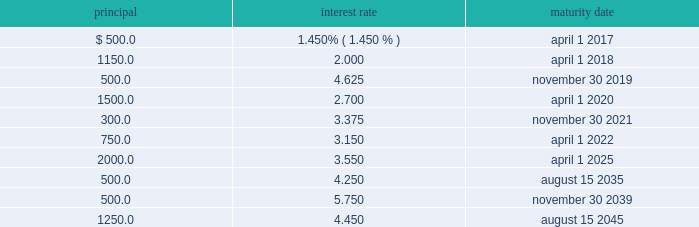Zimmer biomet holdings , inc .
2015 form 10-k annual report through february 25 , 2016 , we repurchased approximately $ 415.0 million of shares of our common stock , which includes the $ 250.0 million of shares that we repurchased from certain selling stockholders on february 10 , 2016 .
In order to achieve operational synergies , we expect cash outlays related to our integration plans to be approximately $ 290.0 million in 2016 .
These cash outlays are necessary to achieve our integration goals of net annual pre-tax operating profit synergies of $ 350.0 million by the end of the third year post-closing date .
Also as discussed in note 20 to our consolidated financial statements , as of december 31 , 2015 , a short-term liability of $ 50.0 million and long-term liability of $ 264.6 million related to durom cup product liability claims was recorded on our consolidated balance sheet .
We expect to continue paying these claims over the next few years .
We expect to be reimbursed a portion of these payments for product liability claims from insurance carriers .
As of december 31 , 2015 , we have received a portion of the insurance proceeds we estimate we will recover .
We have a long-term receivable of $ 95.3 million remaining for future expected reimbursements from our insurance carriers .
We also had a short-term liability of $ 33.4 million related to biomet metal-on-metal hip implant claims .
At december 31 , 2015 , we had ten tranches of senior notes outstanding as follows ( dollars in millions ) : principal interest rate maturity date .
We issued $ 7.65 billion of senior notes in march 2015 ( the 201cmerger notes 201d ) , the proceeds of which were used to finance a portion of the cash consideration payable in the biomet merger , pay merger related fees and expenses and pay a portion of biomet 2019s funded debt .
On june 24 , 2015 , we also borrowed $ 3.0 billion on a u.s .
Term loan ( 201cu.s .
Term loan 201d ) to fund the biomet merger .
We may , at our option , redeem our senior notes , in whole or in part , at any time upon payment of the principal , any applicable make-whole premium , and accrued and unpaid interest to the date of redemption .
In addition , the merger notes and the 3.375% ( 3.375 % ) senior notes due 2021 may be redeemed at our option without any make-whole premium at specified dates ranging from one month to six months in advance of the scheduled maturity date .
We have a $ 4.35 billion credit agreement ( 201ccredit agreement 201d ) that contains : ( i ) a 5-year unsecured u.s .
Term loan facility ( 201cu.s .
Term loan facility 201d ) in the principal amount of $ 3.0 billion , and ( ii ) a 5-year unsecured multicurrency revolving facility ( 201cmulticurrency revolving facility 201d ) in the principal amount of $ 1.35 billion .
The multicurrency revolving facility will mature in may 2019 , with two one-year extensions available at our option .
Borrowings under the multicurrency revolving facility may be used for general corporate purposes .
There were no borrowings outstanding under the multicurrency revolving facility as of december 31 , 2015 .
The u.s .
Term loan facility will mature in june 2020 , with principal payments due beginning september 30 , 2015 , as follows : $ 75.0 million on a quarterly basis during the first three years , $ 112.5 million on a quarterly basis during the fourth year , and $ 412.5 million on a quarterly basis during the fifth year .
In 2015 , we paid $ 500.0 million in principal under the u.s .
Term loan facility , resulting in $ 2.5 billion in outstanding borrowings as of december 31 , we and certain of our wholly owned foreign subsidiaries are the borrowers under the credit agreement .
Borrowings under the credit agreement bear interest at floating rates based upon indices determined by the currency of the borrowings plus an applicable margin determined by reference to our senior unsecured long-term credit rating , or at an alternate base rate , or , in the case of borrowings under the multicurrency revolving facility only , at a fixed rate determined through a competitive bid process .
The credit agreement contains customary affirmative and negative covenants and events of default for an unsecured financing arrangement , including , among other things , limitations on consolidations , mergers and sales of assets .
Financial covenants include a consolidated indebtedness to consolidated ebitda ratio of no greater than 5.0 to 1.0 through june 24 , 2016 and no greater than 4.5 to 1.0 thereafter .
If our credit rating falls below investment grade , additional restrictions would result , including restrictions on investments and payment of dividends .
We were in compliance with all covenants under the credit agreement as of december 31 , 2015 .
Commitments under the credit agreement are subject to certain fees .
On the multicurrency revolving facility , we pay a facility fee at a rate determined by reference to our senior unsecured long-term credit rating .
We have a japan term loan agreement with one of the lenders under the credit agreement for 11.7 billion japanese yen that will mature on may 31 , 2018 .
Borrowings under the japan term loan bear interest at a fixed rate of 0.61 percent per annum until maturity .
We also have other available uncommitted credit facilities totaling $ 35.8 million .
We place our cash and cash equivalents in highly-rated financial institutions and limit the amount of credit exposure to any one entity .
We invest only in high-quality financial instruments in accordance with our internal investment policy .
As of december 31 , 2015 , we had short-term and long-term investments in debt securities with a fair value of $ 273.1 million .
These investments are in debt securities of many different issuers and , therefore , we believe we have no significant concentration of risk with a single issuer .
All of these debt securities remain highly rated and we believe the risk of default by the issuers is low. .
What is the $ 500.0 million in principal paid in 2015 as a percentage of the $ 2.5 billion in outstanding borrowings? 
Computations: (500.0 / (2.5 * 1000))
Answer: 0.2. 